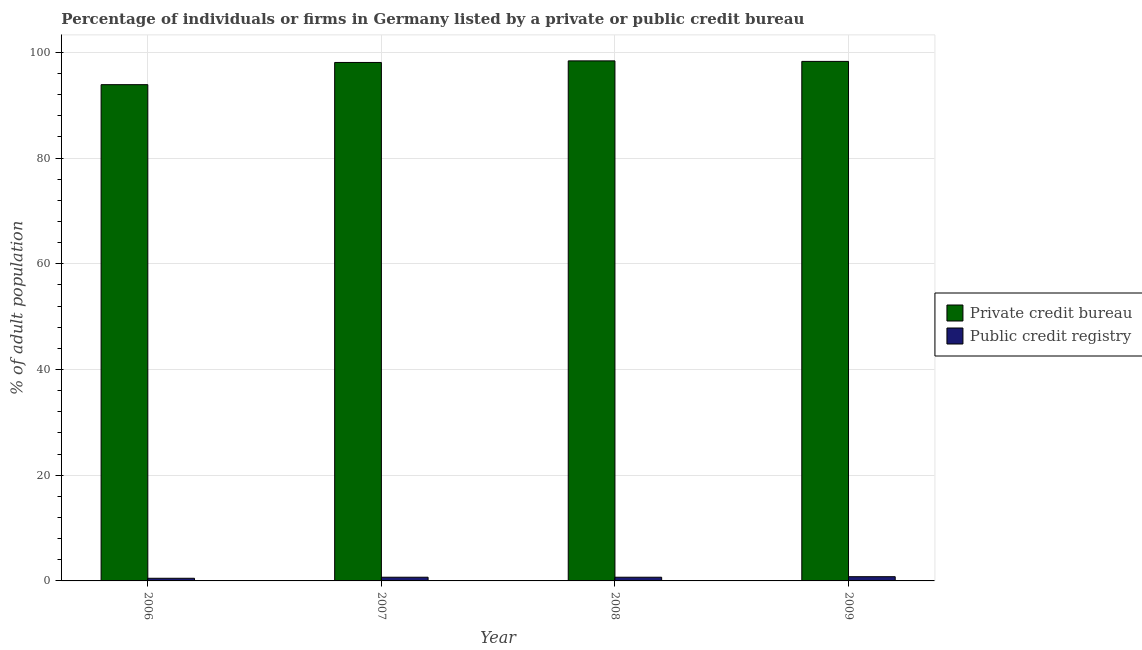Are the number of bars on each tick of the X-axis equal?
Provide a succinct answer. Yes. How many bars are there on the 2nd tick from the right?
Ensure brevity in your answer.  2. In how many cases, is the number of bars for a given year not equal to the number of legend labels?
Offer a very short reply. 0. What is the percentage of firms listed by private credit bureau in 2009?
Ensure brevity in your answer.  98.3. Across all years, what is the maximum percentage of firms listed by public credit bureau?
Your answer should be very brief. 0.8. Across all years, what is the minimum percentage of firms listed by private credit bureau?
Your answer should be very brief. 93.9. In which year was the percentage of firms listed by private credit bureau maximum?
Ensure brevity in your answer.  2008. What is the difference between the percentage of firms listed by private credit bureau in 2006 and that in 2007?
Provide a succinct answer. -4.2. What is the difference between the percentage of firms listed by private credit bureau in 2009 and the percentage of firms listed by public credit bureau in 2008?
Your response must be concise. -0.1. What is the average percentage of firms listed by public credit bureau per year?
Ensure brevity in your answer.  0.68. In the year 2006, what is the difference between the percentage of firms listed by public credit bureau and percentage of firms listed by private credit bureau?
Your answer should be very brief. 0. In how many years, is the percentage of firms listed by private credit bureau greater than 36 %?
Provide a succinct answer. 4. What is the ratio of the percentage of firms listed by public credit bureau in 2006 to that in 2008?
Make the answer very short. 0.71. Is the percentage of firms listed by public credit bureau in 2007 less than that in 2009?
Offer a terse response. Yes. What is the difference between the highest and the second highest percentage of firms listed by public credit bureau?
Ensure brevity in your answer.  0.1. What does the 1st bar from the left in 2007 represents?
Keep it short and to the point. Private credit bureau. What does the 1st bar from the right in 2008 represents?
Offer a terse response. Public credit registry. Are all the bars in the graph horizontal?
Your response must be concise. No. What is the difference between two consecutive major ticks on the Y-axis?
Offer a very short reply. 20. Are the values on the major ticks of Y-axis written in scientific E-notation?
Keep it short and to the point. No. Does the graph contain grids?
Provide a succinct answer. Yes. How many legend labels are there?
Your answer should be compact. 2. What is the title of the graph?
Provide a succinct answer. Percentage of individuals or firms in Germany listed by a private or public credit bureau. What is the label or title of the X-axis?
Make the answer very short. Year. What is the label or title of the Y-axis?
Offer a terse response. % of adult population. What is the % of adult population of Private credit bureau in 2006?
Your response must be concise. 93.9. What is the % of adult population in Private credit bureau in 2007?
Your answer should be very brief. 98.1. What is the % of adult population in Private credit bureau in 2008?
Your answer should be compact. 98.4. What is the % of adult population in Public credit registry in 2008?
Give a very brief answer. 0.7. What is the % of adult population in Private credit bureau in 2009?
Your answer should be very brief. 98.3. What is the % of adult population of Public credit registry in 2009?
Provide a short and direct response. 0.8. Across all years, what is the maximum % of adult population in Private credit bureau?
Provide a short and direct response. 98.4. Across all years, what is the minimum % of adult population in Private credit bureau?
Provide a short and direct response. 93.9. What is the total % of adult population in Private credit bureau in the graph?
Ensure brevity in your answer.  388.7. What is the total % of adult population of Public credit registry in the graph?
Provide a succinct answer. 2.7. What is the difference between the % of adult population in Private credit bureau in 2006 and that in 2007?
Provide a short and direct response. -4.2. What is the difference between the % of adult population in Private credit bureau in 2006 and that in 2008?
Offer a very short reply. -4.5. What is the difference between the % of adult population of Public credit registry in 2006 and that in 2008?
Provide a succinct answer. -0.2. What is the difference between the % of adult population of Private credit bureau in 2006 and that in 2009?
Provide a succinct answer. -4.4. What is the difference between the % of adult population of Public credit registry in 2006 and that in 2009?
Ensure brevity in your answer.  -0.3. What is the difference between the % of adult population of Private credit bureau in 2008 and that in 2009?
Provide a short and direct response. 0.1. What is the difference between the % of adult population in Private credit bureau in 2006 and the % of adult population in Public credit registry in 2007?
Provide a short and direct response. 93.2. What is the difference between the % of adult population in Private credit bureau in 2006 and the % of adult population in Public credit registry in 2008?
Your answer should be compact. 93.2. What is the difference between the % of adult population in Private credit bureau in 2006 and the % of adult population in Public credit registry in 2009?
Your answer should be compact. 93.1. What is the difference between the % of adult population in Private credit bureau in 2007 and the % of adult population in Public credit registry in 2008?
Your answer should be very brief. 97.4. What is the difference between the % of adult population in Private credit bureau in 2007 and the % of adult population in Public credit registry in 2009?
Your answer should be compact. 97.3. What is the difference between the % of adult population in Private credit bureau in 2008 and the % of adult population in Public credit registry in 2009?
Offer a terse response. 97.6. What is the average % of adult population in Private credit bureau per year?
Keep it short and to the point. 97.17. What is the average % of adult population of Public credit registry per year?
Your answer should be compact. 0.68. In the year 2006, what is the difference between the % of adult population in Private credit bureau and % of adult population in Public credit registry?
Provide a short and direct response. 93.4. In the year 2007, what is the difference between the % of adult population in Private credit bureau and % of adult population in Public credit registry?
Ensure brevity in your answer.  97.4. In the year 2008, what is the difference between the % of adult population in Private credit bureau and % of adult population in Public credit registry?
Offer a terse response. 97.7. In the year 2009, what is the difference between the % of adult population of Private credit bureau and % of adult population of Public credit registry?
Make the answer very short. 97.5. What is the ratio of the % of adult population of Private credit bureau in 2006 to that in 2007?
Your answer should be compact. 0.96. What is the ratio of the % of adult population of Private credit bureau in 2006 to that in 2008?
Your response must be concise. 0.95. What is the ratio of the % of adult population in Private credit bureau in 2006 to that in 2009?
Your response must be concise. 0.96. What is the ratio of the % of adult population in Public credit registry in 2006 to that in 2009?
Ensure brevity in your answer.  0.62. What is the ratio of the % of adult population of Private credit bureau in 2007 to that in 2008?
Your response must be concise. 1. What is the ratio of the % of adult population in Public credit registry in 2007 to that in 2008?
Provide a succinct answer. 1. What is the ratio of the % of adult population of Private credit bureau in 2008 to that in 2009?
Keep it short and to the point. 1. What is the difference between the highest and the second highest % of adult population in Private credit bureau?
Ensure brevity in your answer.  0.1. 